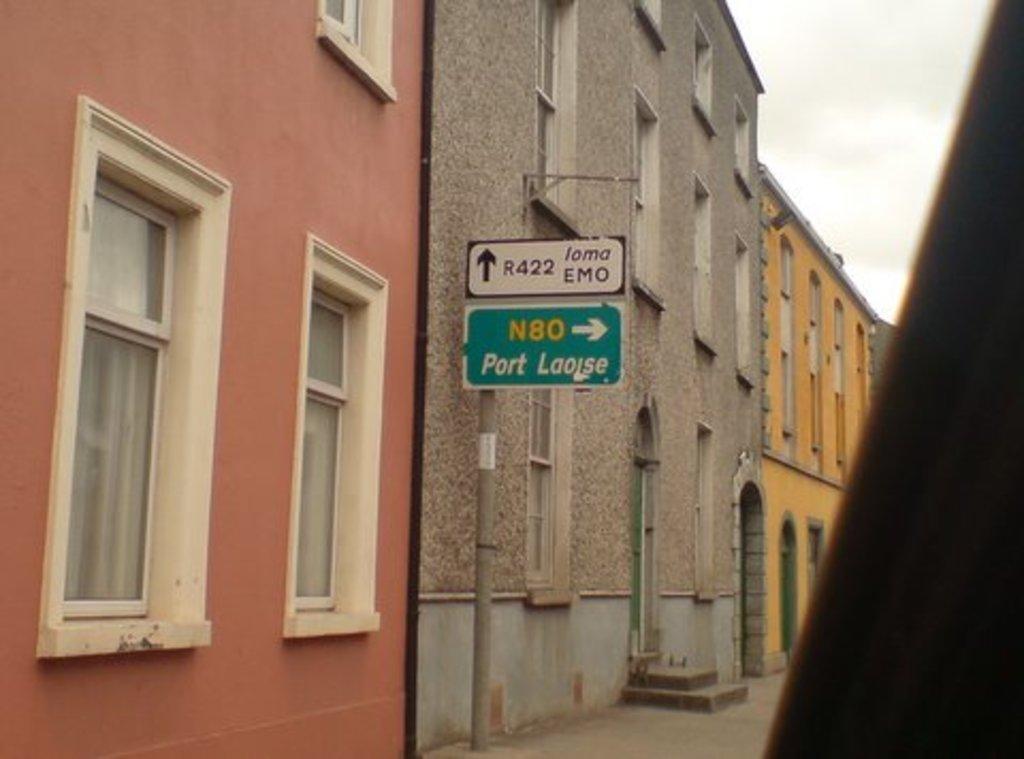Could you give a brief overview of what you see in this image? In this image there are few boards attached to the pole. Behind there are few buildings. Right top there is sky. 